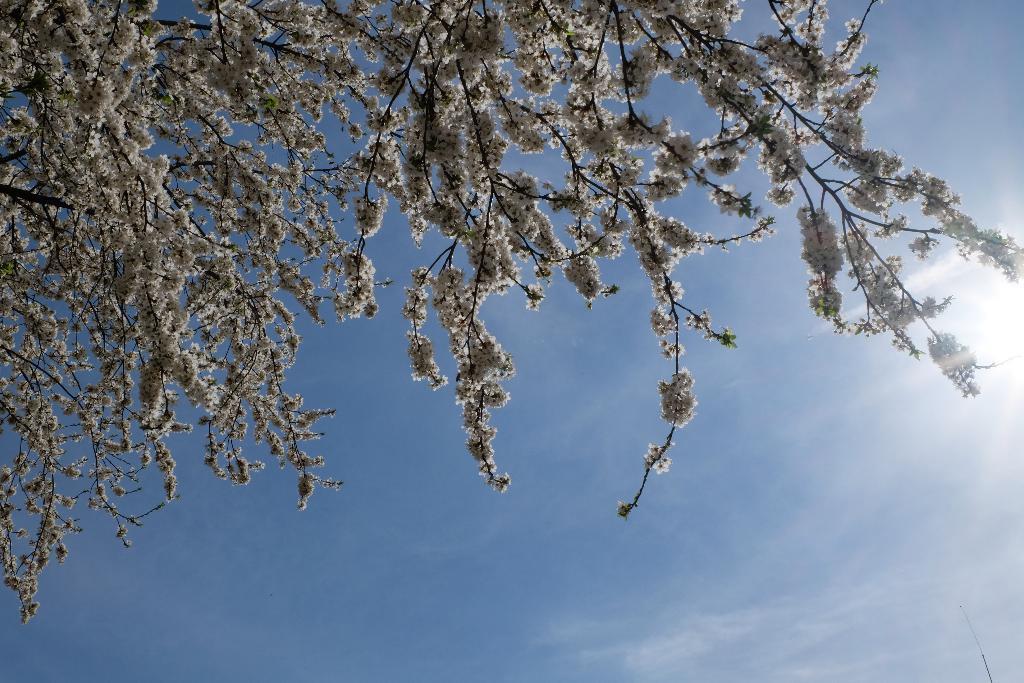How would you summarize this image in a sentence or two? In this image I can see few white color flowers. The sky is in blue and white color. 